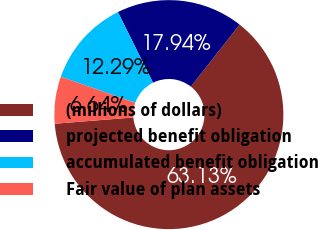Convert chart to OTSL. <chart><loc_0><loc_0><loc_500><loc_500><pie_chart><fcel>(millions of dollars)<fcel>projected benefit obligation<fcel>accumulated benefit obligation<fcel>Fair value of plan assets<nl><fcel>63.14%<fcel>17.94%<fcel>12.29%<fcel>6.64%<nl></chart> 